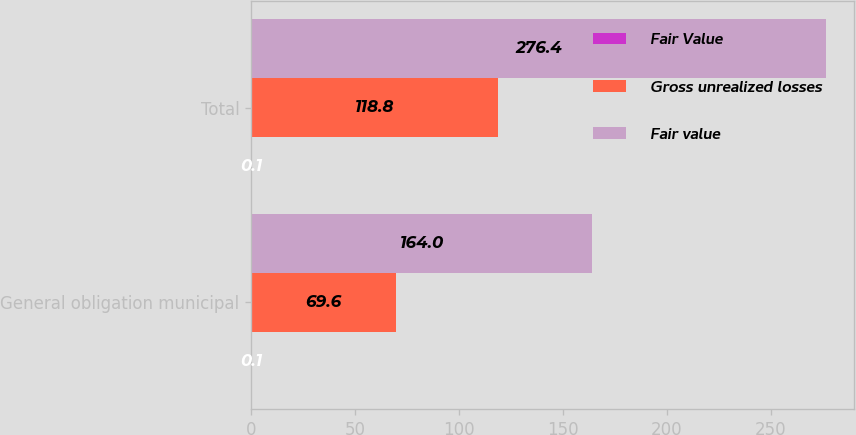<chart> <loc_0><loc_0><loc_500><loc_500><stacked_bar_chart><ecel><fcel>General obligation municipal<fcel>Total<nl><fcel>Fair Value<fcel>0.1<fcel>0.1<nl><fcel>Gross unrealized losses<fcel>69.6<fcel>118.8<nl><fcel>Fair value<fcel>164<fcel>276.4<nl></chart> 